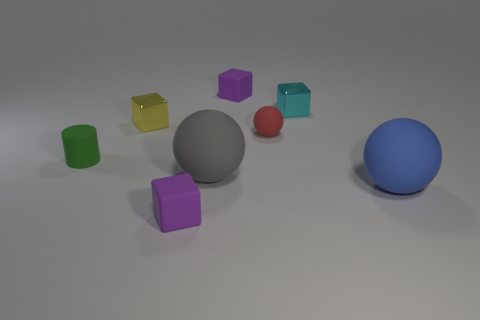Add 2 metallic objects. How many objects exist? 10 Subtract all cylinders. How many objects are left? 7 Add 4 tiny red matte spheres. How many tiny red matte spheres are left? 5 Add 5 small purple matte cubes. How many small purple matte cubes exist? 7 Subtract 0 brown balls. How many objects are left? 8 Subtract all cylinders. Subtract all yellow blocks. How many objects are left? 6 